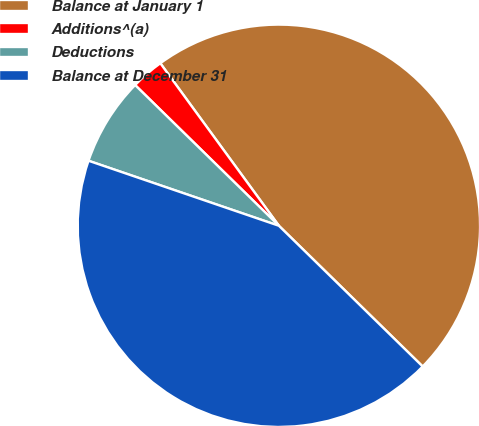Convert chart to OTSL. <chart><loc_0><loc_0><loc_500><loc_500><pie_chart><fcel>Balance at January 1<fcel>Additions^(a)<fcel>Deductions<fcel>Balance at December 31<nl><fcel>47.36%<fcel>2.64%<fcel>7.09%<fcel>42.91%<nl></chart> 